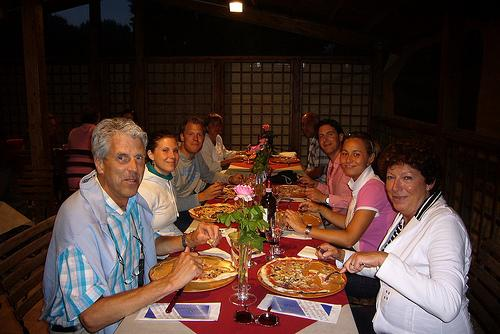Point out the type of flower that is on the table and mention its color. A small pink flower, which is a single pink rose, is sitting in a vase on the table. Identify an object in the image and explain how it relates to food or eating. A fork in a pizza is an object in the image, and it relates to eating as it is used as cutlery for consuming the pizza. Identify the gender of the person wearing a pink and white outfit and mention their shirt color. The person wearing a pink and white outfit is a young woman, and her shirt color is pink. What is the most striking feature of the tablecloth and explain why you think so. The tablecloth is red and white, which is eye-catching due to its vibrant contrasting colors. What's the primary color identifier of the man wearing a checkered shirt in the image? Gray hair. How many lights are visible in the image and briefly describe where they are located. There is one light visible in the image, which is on the ceiling. Estimate how many people are participating in the image scene and describe their seating arrangement. Eight people are sitting together at a table, dining, and having a conversation while they eat pizzas. Mention an accessory that is on the table and describe its placement. A pair of sunglasses is on the table, lying close to the edge with the table cloth beneath. Identify the type of meal from the image and give a brief description of it. People are having individual pizzas for the meal in a social gathering, with eight people dining at one table during nighttime. Name two clothing styles that can be observed in the image. A man with a sweater draped over his shoulders, and a woman wearing a white sweater with a striped shirt. Which famous painting does the room separator resemble? B) The Scream Read the text on the brown beer bottle using OCR. There is no text visible on the brown beer bottle. Create a short multi-modal story based on the people eating together. Under the golden glow of the ceiling light, a joyful group of eight friends gathers to share laughter and stories over plates of delicious pizza. Each guest sports their own unique style, from the man with a checkered shirt and gray hair to the young woman adorned in pink and white. Amid the vibrant red and white tablecloth, a single pink rose in a vase serves as an elegant centerpiece for the special occasion. A group of kids can be seen playing in the background near the window. Their laughter and playful nature are contagious. There's no mention of kids playing or even the existence of a window in the image, so this is a non-existent scene that would be misleading. What can be seen hanging from the man's neck? reading glasses Describe the pattern of the tablecloth. red and white checkered From the objects on the table, describe the weather outside. It is nighttime, as inferred from the picture being taken at night. What kind of flower can be seen on the table? small pink rose Recognize the activities portrayed in the diagram. There is no diagram to recognize activities from Look for the tall, bright green potted plant in the left corner of the image. The plant adds a touch of nature to the indoor dining experience. There is no mention of a plant, potted or otherwise, in the list of objects in the image. Therefore, this object does not exist, and the instruction is misleading. What utensil is the woman using to cut the pizza? fork Did you notice the colorful birthday cake with flickering candles on the table? Count the number of candles and tell us the age being celebrated. There is no mention of a birthday cake or candles in any of the objects listed, so this object is misleading and not present in the image. In a poetic manner, describe the small pink flower on the table. A delicate pink bloom rests in a vase, adding a touch of gentle beauty to the lively gathering. What is the position of the sunglasses on the table? laying down Identify the color combination of the napkin on the table. blue and white What are the main colors of the table cloth? white and red Describe the emotional expression of the woman looking at the camera. smiling and happy What color is the shirt of the man with gray hair? checkered Elaborate on the attire of the woman in the white jacket and black and white shirt. The woman dons a chic white jacket with a fashionable black and white striped shirt underneath. Identify the type of food being served at the table. individual pizzas On the table, there's a hot steaming bowl of delicious soup next to a beautifully designed pot. Please take note of the vibrant colors and intricate patterns on the pot. None of the objects mention a bowl of soup or a beautifully designed pot, which means these objects don't exist in the image. Can you spot the small white dog sitting just under the table in the corner? Look for a furry, four-legged friend. There is no mention of any animal, specifically a dog, in any of the objects or captions, so it is misleading and non-existent. What is the color of the light on the ceiling? white Which object can be found at the center of the image with eight people dining? food, specifically pizzas How many people are sitting at the table? eight people Did you notice a couple dancing and laughing just outside the dining area? Their joy and happiness bring life to the party. None of the objects or captions imply the presence of a dancing couple or an outside area, making this instruction misleading and based on non-existent objects. 